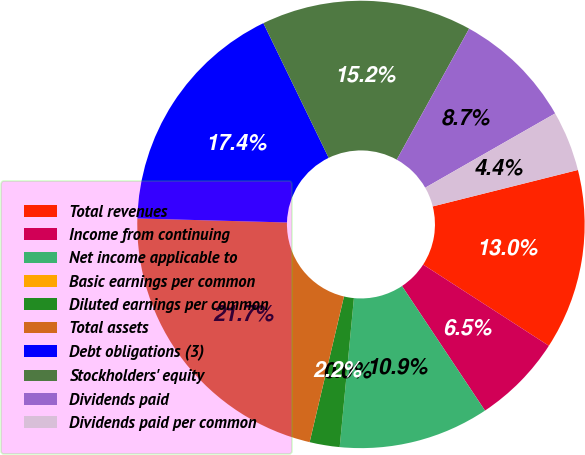Convert chart. <chart><loc_0><loc_0><loc_500><loc_500><pie_chart><fcel>Total revenues<fcel>Income from continuing<fcel>Net income applicable to<fcel>Basic earnings per common<fcel>Diluted earnings per common<fcel>Total assets<fcel>Debt obligations (3)<fcel>Stockholders' equity<fcel>Dividends paid<fcel>Dividends paid per common<nl><fcel>13.04%<fcel>6.52%<fcel>10.87%<fcel>0.0%<fcel>2.17%<fcel>21.74%<fcel>17.39%<fcel>15.22%<fcel>8.7%<fcel>4.35%<nl></chart> 